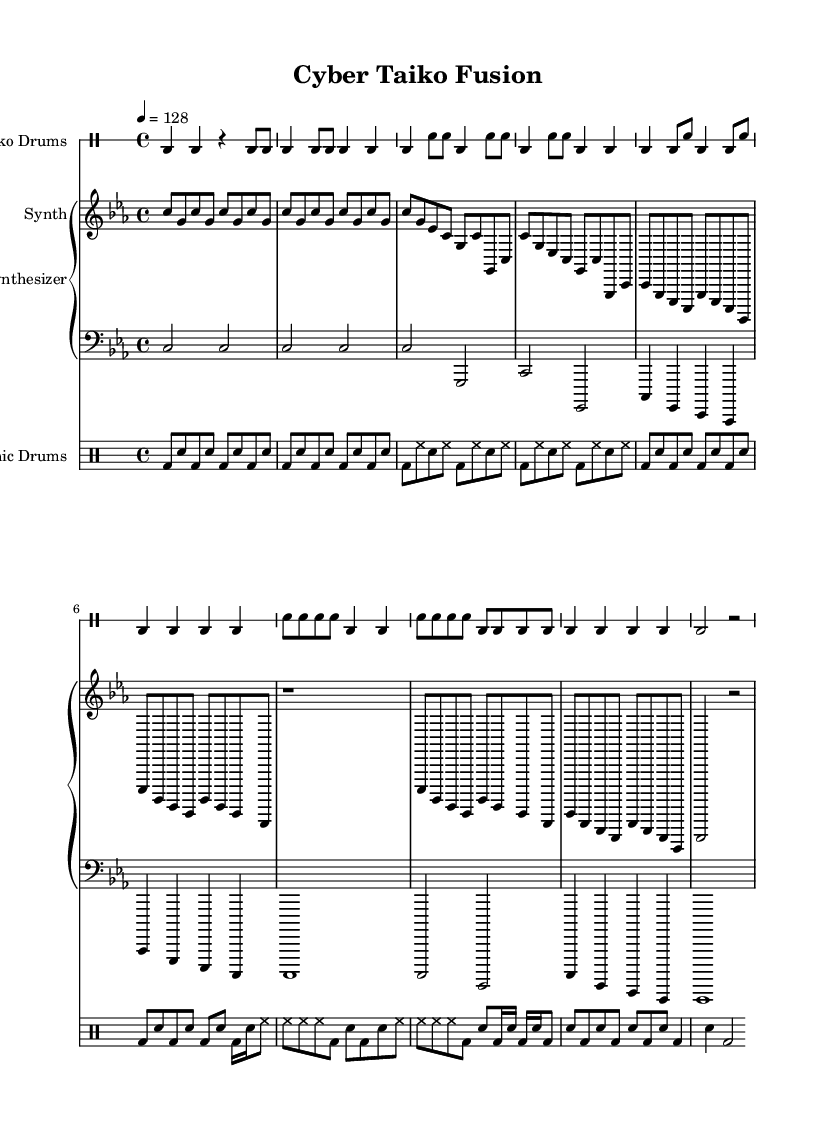What is the key signature of this music? The key signature is C minor, indicated by the presence of three flats (B♭, E♭, A♭) found at the beginning of the staff.
Answer: C minor What is the time signature of this piece? The time signature is 4/4, shown at the beginning of the score with the numbers placed in a fraction format. This means there are four beats in each measure and the quarter note receives one beat.
Answer: 4/4 What is the tempo marking given in the score? The tempo marking indicates that the piece should be played at a speed of 128 beats per minute, which is specified at the start of the music.
Answer: 128 How many measures are in the intro section? By counting the measures from the 'Intro' section in the taiko drums part specifically, there are a total of 4 measures dedicated to this section in the provided music.
Answer: 4 Which instruments are used in this composition? The score features Taiko Drums, Synthesizer, and Electronic Drums as the primary instruments, all indicated at the beginning of their respective staves.
Answer: Taiko Drums, Synthesizer, Electronic Drums How does the rhythm change from the Verse to the Chorus? The rhythm changes in the Chorus where there is a shift in the distribution and density of notes, with the inclusion of double notes (sixteenth notes) which increases the rhythmic complexity compared to the simpler patterns in the Verse.
Answer: More complex What is the function of the electronic drums in this piece? The electronic drums add a layer of urgency and modernity to the piece, providing a driving rhythm that complements the traditional Taiko Drums, creating a fusion of styles reflective of the industrial techno genre.
Answer: Fusion of styles 